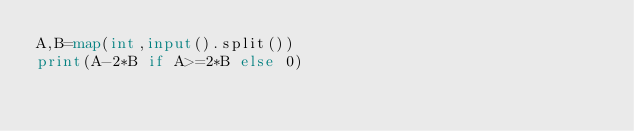<code> <loc_0><loc_0><loc_500><loc_500><_Python_>A,B=map(int,input().split())
print(A-2*B if A>=2*B else 0)</code> 